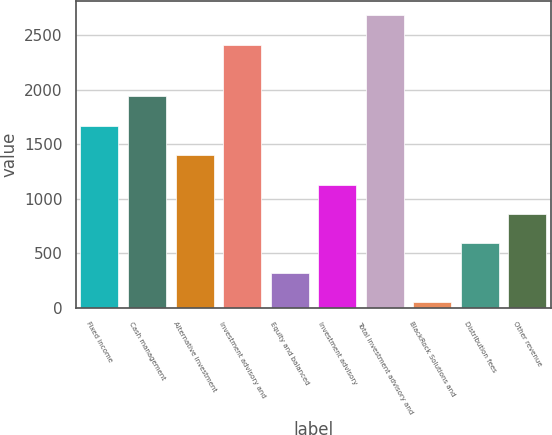Convert chart. <chart><loc_0><loc_0><loc_500><loc_500><bar_chart><fcel>Fixed income<fcel>Cash management<fcel>Alternative investment<fcel>Investment advisory and<fcel>Equity and balanced<fcel>Investment advisory<fcel>Total investment advisory and<fcel>BlackRock Solutions and<fcel>Distribution fees<fcel>Other revenue<nl><fcel>1668.2<fcel>1937.9<fcel>1398.5<fcel>2411<fcel>319.7<fcel>1128.8<fcel>2680.7<fcel>50<fcel>589.4<fcel>859.1<nl></chart> 